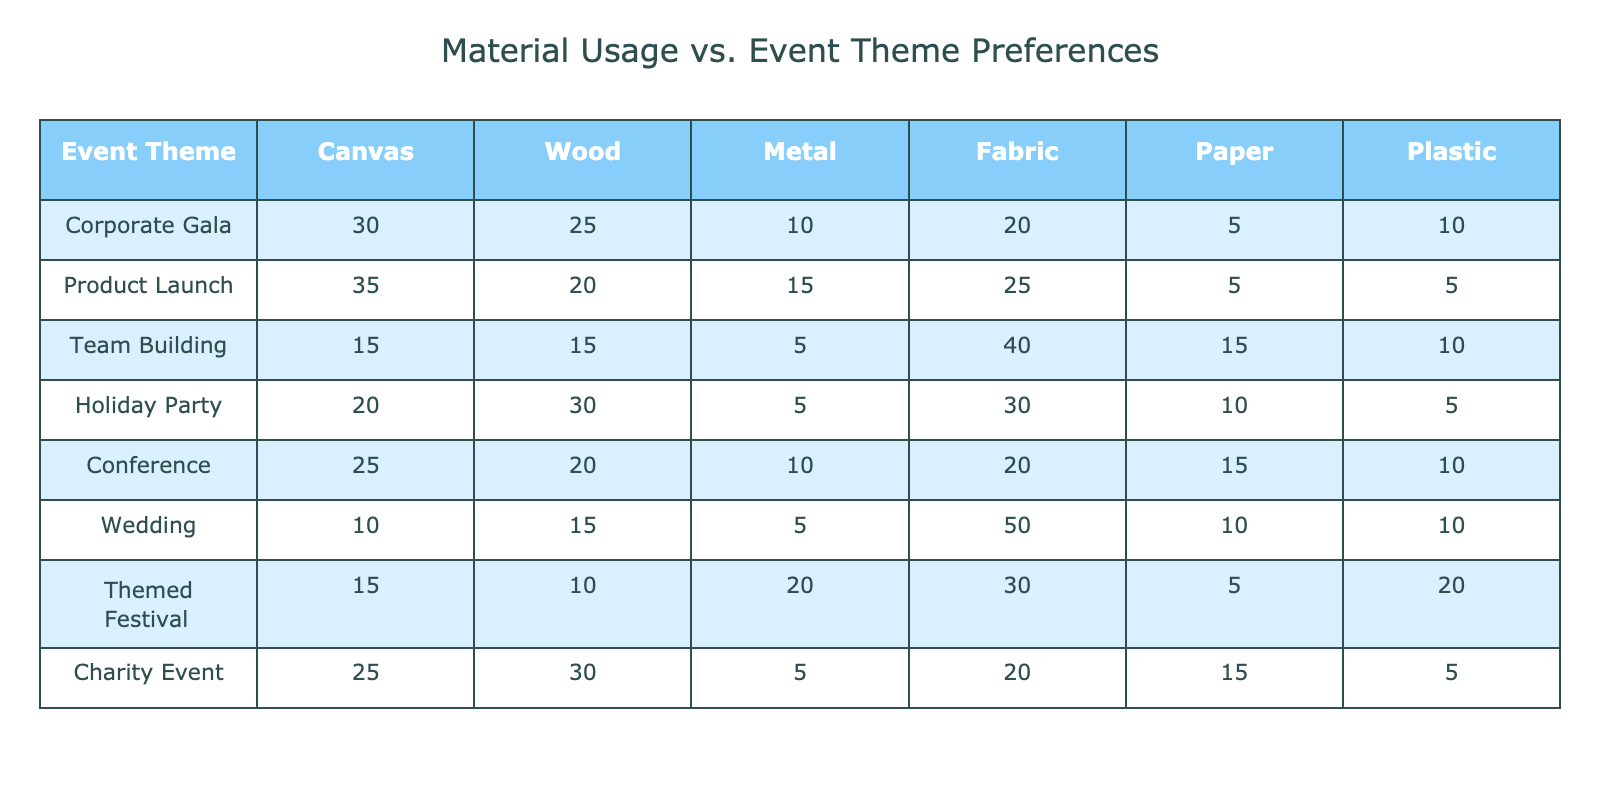What is the highest material usage for a Corporate Gala? In the row for the Corporate Gala, the materials used are as follows: Canvas (30), Wood (25), Metal (10), Fabric (20), Paper (5), Plastic (10). The highest usage is Canvas at 30.
Answer: 30 Which event theme uses the most Fabric in total? To find the total Fabric usage, we can check all event themes where Fabric usage is listed: Team Building (40), Wedding (50), Holiday Party (30), Corporate Gala (20), Product Launch (25), Conference (20), Themed Festival (30), and Charity Event (20). The Wedding has the highest Fabric usage at 50.
Answer: Wedding Is Paper usage greater than Wood usage for the Themed Festival? In the Themed Festival row, Paper usage is 5, while Wood usage is 10. Since 5 is not greater than 10, the answer is no.
Answer: No What events have Wood usage greater than 25? Looking at the Wood usage values: Corporate Gala (25), Product Launch (20), Team Building (15), Holiday Party (30), Conference (20), Wedding (15), Themed Festival (10), Charity Event (30). The Holiday Party (30) and Charity Event (30) both have Wood usage greater than 25.
Answer: Holiday Party, Charity Event What is the average usage of Metal across all event themes? To calculate the average Metal usage, we sum the Metal usage for all events: 10 (Corporate Gala) + 15 (Product Launch) + 5 (Team Building) + 5 (Holiday Party) + 10 (Conference) + 5 (Wedding) + 20 (Themed Festival) + 5 (Charity Event) = 75. There are 8 events, so the average is 75/8 = 9.375.
Answer: 9.375 Does the Team Building event have more usage of Plastic than the Conference event? Checking the Plastic usage: Team Building (10) and Conference (10). Since both values are equal, Team Building does not have more Plastic usage than Conference.
Answer: No What is the total usage of Canvas for all events? The Canvas usage values are: 30 (Corporate Gala), 35 (Product Launch), 15 (Team Building), 20 (Holiday Party), 25 (Conference), 10 (Wedding), 15 (Themed Festival), and 25 (Charity Event). Adding these values gives us 30 + 35 + 15 + 20 + 25 + 10 + 15 + 25 = 175.
Answer: 175 Which event has the least usage of Paper? Paper usage values are as follows: 5 (Corporate Gala), 5 (Product Launch), 15 (Team Building), 10 (Holiday Party), 15 (Conference), 10 (Wedding), 5 (Themed Festival), and 20 (Charity Event). Both Corporate Gala and Product Launch, as well as Themed Festival, have the least Paper usage of 5.
Answer: Corporate Gala, Product Launch, Themed Festival 